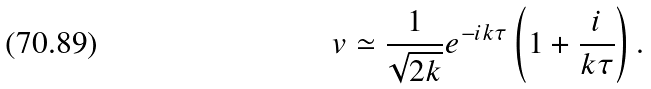<formula> <loc_0><loc_0><loc_500><loc_500>v \simeq \frac { 1 } { \sqrt { 2 k } } e ^ { - i k \tau } \left ( 1 + \frac { i } { k \tau } \right ) .</formula> 